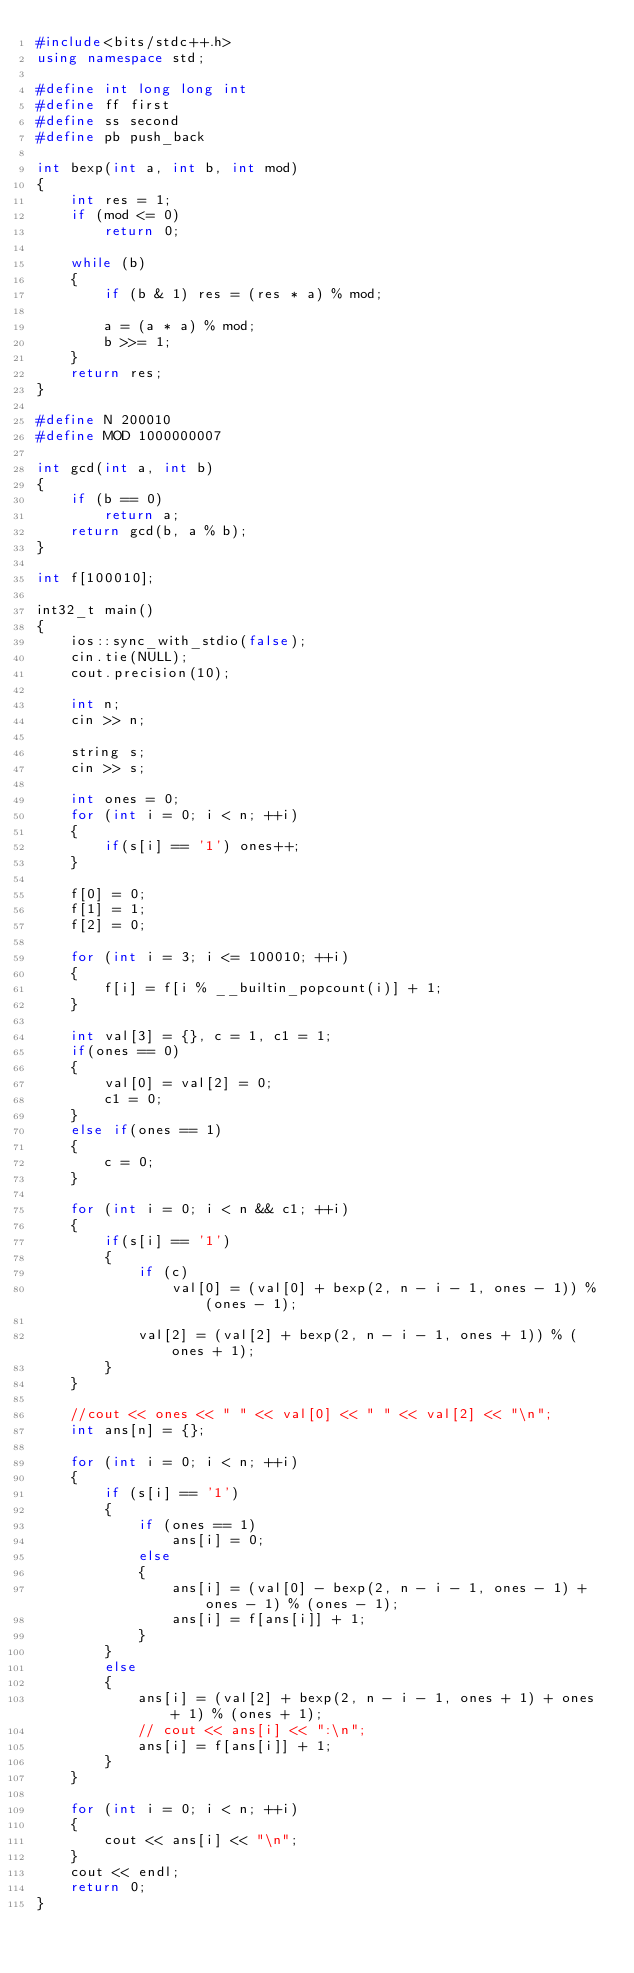<code> <loc_0><loc_0><loc_500><loc_500><_C++_>#include<bits/stdc++.h>
using namespace std;

#define int long long int
#define ff first
#define ss second
#define pb push_back

int bexp(int a, int b, int mod)
{
    int res = 1;
    if (mod <= 0)
        return 0;

    while (b)
    {
        if (b & 1) res = (res * a) % mod;

        a = (a * a) % mod; 
        b >>= 1;
    }
    return res;
}

#define N 200010
#define MOD 1000000007

int gcd(int a, int b)
{
    if (b == 0)
        return a;
    return gcd(b, a % b);
}

int f[100010];

int32_t main()
{
    ios::sync_with_stdio(false);
    cin.tie(NULL);
    cout.precision(10);

    int n;
    cin >> n;

    string s;
    cin >> s;
    
    int ones = 0;
    for (int i = 0; i < n; ++i)
    {
        if(s[i] == '1') ones++;
    }

    f[0] = 0;
    f[1] = 1;
    f[2] = 0;

    for (int i = 3; i <= 100010; ++i)
    {
        f[i] = f[i % __builtin_popcount(i)] + 1;
    }

    int val[3] = {}, c = 1, c1 = 1;
    if(ones == 0)
    {
        val[0] = val[2] = 0;
        c1 = 0;
    }
    else if(ones == 1)
    {
        c = 0;
    }
    
    for (int i = 0; i < n && c1; ++i)
    {
        if(s[i] == '1')
        {
            if (c)
                val[0] = (val[0] + bexp(2, n - i - 1, ones - 1)) % (ones - 1);
        
            val[2] = (val[2] + bexp(2, n - i - 1, ones + 1)) % (ones + 1);
        }
    }

    //cout << ones << " " << val[0] << " " << val[2] << "\n";
    int ans[n] = {};
    
    for (int i = 0; i < n; ++i)
    {
        if (s[i] == '1')
        {
            if (ones == 1)
                ans[i] = 0;
            else
            {
                ans[i] = (val[0] - bexp(2, n - i - 1, ones - 1) + ones - 1) % (ones - 1);
                ans[i] = f[ans[i]] + 1;
            }
        }
        else
        {
            ans[i] = (val[2] + bexp(2, n - i - 1, ones + 1) + ones + 1) % (ones + 1);
            // cout << ans[i] << ":\n";
            ans[i] = f[ans[i]] + 1;
        }
    }

    for (int i = 0; i < n; ++i)
    {
        cout << ans[i] << "\n";
    }
    cout << endl;
    return 0;
}
</code> 